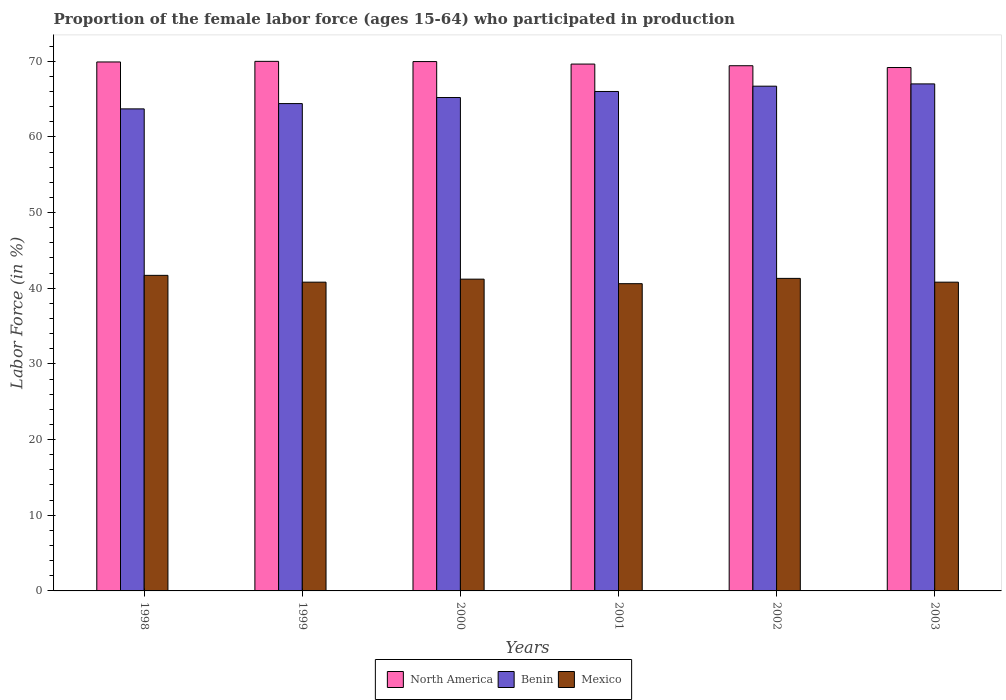How many different coloured bars are there?
Your answer should be compact. 3. How many groups of bars are there?
Provide a succinct answer. 6. Are the number of bars per tick equal to the number of legend labels?
Make the answer very short. Yes. What is the label of the 5th group of bars from the left?
Offer a terse response. 2002. In how many cases, is the number of bars for a given year not equal to the number of legend labels?
Provide a short and direct response. 0. What is the proportion of the female labor force who participated in production in North America in 2000?
Your answer should be very brief. 69.95. Across all years, what is the maximum proportion of the female labor force who participated in production in Benin?
Give a very brief answer. 67. Across all years, what is the minimum proportion of the female labor force who participated in production in Benin?
Provide a short and direct response. 63.7. What is the total proportion of the female labor force who participated in production in Benin in the graph?
Give a very brief answer. 393. What is the difference between the proportion of the female labor force who participated in production in Mexico in 2000 and that in 2002?
Your response must be concise. -0.1. What is the difference between the proportion of the female labor force who participated in production in Benin in 2000 and the proportion of the female labor force who participated in production in Mexico in 1998?
Ensure brevity in your answer.  23.5. What is the average proportion of the female labor force who participated in production in Mexico per year?
Ensure brevity in your answer.  41.07. In the year 2001, what is the difference between the proportion of the female labor force who participated in production in North America and proportion of the female labor force who participated in production in Benin?
Offer a very short reply. 3.62. What is the ratio of the proportion of the female labor force who participated in production in Benin in 1999 to that in 2002?
Keep it short and to the point. 0.97. Is the proportion of the female labor force who participated in production in Mexico in 1998 less than that in 2003?
Offer a terse response. No. What is the difference between the highest and the second highest proportion of the female labor force who participated in production in North America?
Provide a succinct answer. 0.03. What is the difference between the highest and the lowest proportion of the female labor force who participated in production in Benin?
Give a very brief answer. 3.3. In how many years, is the proportion of the female labor force who participated in production in North America greater than the average proportion of the female labor force who participated in production in North America taken over all years?
Your answer should be very brief. 3. Is the sum of the proportion of the female labor force who participated in production in Benin in 2002 and 2003 greater than the maximum proportion of the female labor force who participated in production in North America across all years?
Provide a short and direct response. Yes. What does the 1st bar from the left in 1999 represents?
Your answer should be very brief. North America. What does the 2nd bar from the right in 1998 represents?
Provide a short and direct response. Benin. Are all the bars in the graph horizontal?
Your answer should be compact. No. Are the values on the major ticks of Y-axis written in scientific E-notation?
Provide a succinct answer. No. Does the graph contain any zero values?
Keep it short and to the point. No. Does the graph contain grids?
Keep it short and to the point. No. Where does the legend appear in the graph?
Ensure brevity in your answer.  Bottom center. How many legend labels are there?
Give a very brief answer. 3. How are the legend labels stacked?
Offer a terse response. Horizontal. What is the title of the graph?
Make the answer very short. Proportion of the female labor force (ages 15-64) who participated in production. What is the label or title of the X-axis?
Your response must be concise. Years. What is the Labor Force (in %) in North America in 1998?
Give a very brief answer. 69.9. What is the Labor Force (in %) of Benin in 1998?
Provide a succinct answer. 63.7. What is the Labor Force (in %) of Mexico in 1998?
Ensure brevity in your answer.  41.7. What is the Labor Force (in %) of North America in 1999?
Provide a short and direct response. 69.98. What is the Labor Force (in %) of Benin in 1999?
Offer a very short reply. 64.4. What is the Labor Force (in %) of Mexico in 1999?
Make the answer very short. 40.8. What is the Labor Force (in %) in North America in 2000?
Offer a very short reply. 69.95. What is the Labor Force (in %) of Benin in 2000?
Provide a short and direct response. 65.2. What is the Labor Force (in %) of Mexico in 2000?
Offer a very short reply. 41.2. What is the Labor Force (in %) of North America in 2001?
Offer a terse response. 69.62. What is the Labor Force (in %) of Mexico in 2001?
Provide a succinct answer. 40.6. What is the Labor Force (in %) of North America in 2002?
Ensure brevity in your answer.  69.4. What is the Labor Force (in %) of Benin in 2002?
Provide a succinct answer. 66.7. What is the Labor Force (in %) in Mexico in 2002?
Make the answer very short. 41.3. What is the Labor Force (in %) of North America in 2003?
Make the answer very short. 69.16. What is the Labor Force (in %) in Mexico in 2003?
Make the answer very short. 40.8. Across all years, what is the maximum Labor Force (in %) of North America?
Make the answer very short. 69.98. Across all years, what is the maximum Labor Force (in %) of Benin?
Offer a terse response. 67. Across all years, what is the maximum Labor Force (in %) in Mexico?
Your response must be concise. 41.7. Across all years, what is the minimum Labor Force (in %) in North America?
Provide a succinct answer. 69.16. Across all years, what is the minimum Labor Force (in %) in Benin?
Your answer should be compact. 63.7. Across all years, what is the minimum Labor Force (in %) of Mexico?
Your answer should be compact. 40.6. What is the total Labor Force (in %) in North America in the graph?
Offer a very short reply. 418.02. What is the total Labor Force (in %) in Benin in the graph?
Your response must be concise. 393. What is the total Labor Force (in %) in Mexico in the graph?
Offer a very short reply. 246.4. What is the difference between the Labor Force (in %) of North America in 1998 and that in 1999?
Your answer should be compact. -0.08. What is the difference between the Labor Force (in %) of Benin in 1998 and that in 1999?
Your response must be concise. -0.7. What is the difference between the Labor Force (in %) of Mexico in 1998 and that in 1999?
Provide a succinct answer. 0.9. What is the difference between the Labor Force (in %) of North America in 1998 and that in 2000?
Your response must be concise. -0.05. What is the difference between the Labor Force (in %) of Benin in 1998 and that in 2000?
Provide a succinct answer. -1.5. What is the difference between the Labor Force (in %) of North America in 1998 and that in 2001?
Provide a short and direct response. 0.28. What is the difference between the Labor Force (in %) in Benin in 1998 and that in 2001?
Provide a succinct answer. -2.3. What is the difference between the Labor Force (in %) of North America in 1998 and that in 2002?
Provide a short and direct response. 0.5. What is the difference between the Labor Force (in %) of North America in 1998 and that in 2003?
Your answer should be compact. 0.74. What is the difference between the Labor Force (in %) in Benin in 1998 and that in 2003?
Your answer should be compact. -3.3. What is the difference between the Labor Force (in %) of North America in 1999 and that in 2000?
Offer a very short reply. 0.03. What is the difference between the Labor Force (in %) in Benin in 1999 and that in 2000?
Offer a terse response. -0.8. What is the difference between the Labor Force (in %) in Mexico in 1999 and that in 2000?
Keep it short and to the point. -0.4. What is the difference between the Labor Force (in %) of North America in 1999 and that in 2001?
Provide a succinct answer. 0.36. What is the difference between the Labor Force (in %) in Benin in 1999 and that in 2001?
Make the answer very short. -1.6. What is the difference between the Labor Force (in %) of North America in 1999 and that in 2002?
Make the answer very short. 0.58. What is the difference between the Labor Force (in %) of North America in 1999 and that in 2003?
Offer a terse response. 0.82. What is the difference between the Labor Force (in %) of Benin in 1999 and that in 2003?
Provide a short and direct response. -2.6. What is the difference between the Labor Force (in %) in Mexico in 1999 and that in 2003?
Keep it short and to the point. 0. What is the difference between the Labor Force (in %) of North America in 2000 and that in 2001?
Give a very brief answer. 0.33. What is the difference between the Labor Force (in %) in Benin in 2000 and that in 2001?
Keep it short and to the point. -0.8. What is the difference between the Labor Force (in %) of Mexico in 2000 and that in 2001?
Keep it short and to the point. 0.6. What is the difference between the Labor Force (in %) of North America in 2000 and that in 2002?
Give a very brief answer. 0.55. What is the difference between the Labor Force (in %) of North America in 2000 and that in 2003?
Provide a short and direct response. 0.79. What is the difference between the Labor Force (in %) in Mexico in 2000 and that in 2003?
Your response must be concise. 0.4. What is the difference between the Labor Force (in %) of North America in 2001 and that in 2002?
Provide a short and direct response. 0.22. What is the difference between the Labor Force (in %) in North America in 2001 and that in 2003?
Your answer should be very brief. 0.46. What is the difference between the Labor Force (in %) in Benin in 2001 and that in 2003?
Your answer should be compact. -1. What is the difference between the Labor Force (in %) of Mexico in 2001 and that in 2003?
Provide a succinct answer. -0.2. What is the difference between the Labor Force (in %) in North America in 2002 and that in 2003?
Offer a very short reply. 0.24. What is the difference between the Labor Force (in %) in Mexico in 2002 and that in 2003?
Give a very brief answer. 0.5. What is the difference between the Labor Force (in %) of North America in 1998 and the Labor Force (in %) of Benin in 1999?
Ensure brevity in your answer.  5.5. What is the difference between the Labor Force (in %) in North America in 1998 and the Labor Force (in %) in Mexico in 1999?
Keep it short and to the point. 29.1. What is the difference between the Labor Force (in %) of Benin in 1998 and the Labor Force (in %) of Mexico in 1999?
Your answer should be compact. 22.9. What is the difference between the Labor Force (in %) in North America in 1998 and the Labor Force (in %) in Benin in 2000?
Give a very brief answer. 4.7. What is the difference between the Labor Force (in %) in North America in 1998 and the Labor Force (in %) in Mexico in 2000?
Offer a very short reply. 28.7. What is the difference between the Labor Force (in %) of North America in 1998 and the Labor Force (in %) of Benin in 2001?
Your answer should be very brief. 3.9. What is the difference between the Labor Force (in %) in North America in 1998 and the Labor Force (in %) in Mexico in 2001?
Offer a terse response. 29.3. What is the difference between the Labor Force (in %) in Benin in 1998 and the Labor Force (in %) in Mexico in 2001?
Give a very brief answer. 23.1. What is the difference between the Labor Force (in %) of North America in 1998 and the Labor Force (in %) of Benin in 2002?
Your answer should be compact. 3.2. What is the difference between the Labor Force (in %) of North America in 1998 and the Labor Force (in %) of Mexico in 2002?
Provide a short and direct response. 28.6. What is the difference between the Labor Force (in %) in Benin in 1998 and the Labor Force (in %) in Mexico in 2002?
Provide a short and direct response. 22.4. What is the difference between the Labor Force (in %) of North America in 1998 and the Labor Force (in %) of Benin in 2003?
Your answer should be very brief. 2.9. What is the difference between the Labor Force (in %) of North America in 1998 and the Labor Force (in %) of Mexico in 2003?
Ensure brevity in your answer.  29.1. What is the difference between the Labor Force (in %) in Benin in 1998 and the Labor Force (in %) in Mexico in 2003?
Your answer should be compact. 22.9. What is the difference between the Labor Force (in %) of North America in 1999 and the Labor Force (in %) of Benin in 2000?
Give a very brief answer. 4.78. What is the difference between the Labor Force (in %) of North America in 1999 and the Labor Force (in %) of Mexico in 2000?
Your answer should be very brief. 28.78. What is the difference between the Labor Force (in %) in Benin in 1999 and the Labor Force (in %) in Mexico in 2000?
Your answer should be compact. 23.2. What is the difference between the Labor Force (in %) of North America in 1999 and the Labor Force (in %) of Benin in 2001?
Your answer should be very brief. 3.98. What is the difference between the Labor Force (in %) in North America in 1999 and the Labor Force (in %) in Mexico in 2001?
Give a very brief answer. 29.38. What is the difference between the Labor Force (in %) of Benin in 1999 and the Labor Force (in %) of Mexico in 2001?
Make the answer very short. 23.8. What is the difference between the Labor Force (in %) in North America in 1999 and the Labor Force (in %) in Benin in 2002?
Offer a terse response. 3.28. What is the difference between the Labor Force (in %) of North America in 1999 and the Labor Force (in %) of Mexico in 2002?
Provide a short and direct response. 28.68. What is the difference between the Labor Force (in %) of Benin in 1999 and the Labor Force (in %) of Mexico in 2002?
Keep it short and to the point. 23.1. What is the difference between the Labor Force (in %) of North America in 1999 and the Labor Force (in %) of Benin in 2003?
Your answer should be very brief. 2.98. What is the difference between the Labor Force (in %) in North America in 1999 and the Labor Force (in %) in Mexico in 2003?
Your answer should be very brief. 29.18. What is the difference between the Labor Force (in %) in Benin in 1999 and the Labor Force (in %) in Mexico in 2003?
Your answer should be compact. 23.6. What is the difference between the Labor Force (in %) of North America in 2000 and the Labor Force (in %) of Benin in 2001?
Ensure brevity in your answer.  3.95. What is the difference between the Labor Force (in %) in North America in 2000 and the Labor Force (in %) in Mexico in 2001?
Your answer should be compact. 29.35. What is the difference between the Labor Force (in %) of Benin in 2000 and the Labor Force (in %) of Mexico in 2001?
Give a very brief answer. 24.6. What is the difference between the Labor Force (in %) of North America in 2000 and the Labor Force (in %) of Benin in 2002?
Make the answer very short. 3.25. What is the difference between the Labor Force (in %) in North America in 2000 and the Labor Force (in %) in Mexico in 2002?
Provide a succinct answer. 28.65. What is the difference between the Labor Force (in %) in Benin in 2000 and the Labor Force (in %) in Mexico in 2002?
Your response must be concise. 23.9. What is the difference between the Labor Force (in %) of North America in 2000 and the Labor Force (in %) of Benin in 2003?
Give a very brief answer. 2.95. What is the difference between the Labor Force (in %) in North America in 2000 and the Labor Force (in %) in Mexico in 2003?
Your answer should be compact. 29.15. What is the difference between the Labor Force (in %) of Benin in 2000 and the Labor Force (in %) of Mexico in 2003?
Your answer should be compact. 24.4. What is the difference between the Labor Force (in %) in North America in 2001 and the Labor Force (in %) in Benin in 2002?
Offer a very short reply. 2.92. What is the difference between the Labor Force (in %) in North America in 2001 and the Labor Force (in %) in Mexico in 2002?
Offer a very short reply. 28.32. What is the difference between the Labor Force (in %) of Benin in 2001 and the Labor Force (in %) of Mexico in 2002?
Give a very brief answer. 24.7. What is the difference between the Labor Force (in %) of North America in 2001 and the Labor Force (in %) of Benin in 2003?
Provide a short and direct response. 2.62. What is the difference between the Labor Force (in %) in North America in 2001 and the Labor Force (in %) in Mexico in 2003?
Provide a succinct answer. 28.82. What is the difference between the Labor Force (in %) in Benin in 2001 and the Labor Force (in %) in Mexico in 2003?
Give a very brief answer. 25.2. What is the difference between the Labor Force (in %) in North America in 2002 and the Labor Force (in %) in Benin in 2003?
Your answer should be compact. 2.4. What is the difference between the Labor Force (in %) of North America in 2002 and the Labor Force (in %) of Mexico in 2003?
Ensure brevity in your answer.  28.6. What is the difference between the Labor Force (in %) of Benin in 2002 and the Labor Force (in %) of Mexico in 2003?
Your answer should be very brief. 25.9. What is the average Labor Force (in %) of North America per year?
Provide a short and direct response. 69.67. What is the average Labor Force (in %) in Benin per year?
Your response must be concise. 65.5. What is the average Labor Force (in %) in Mexico per year?
Ensure brevity in your answer.  41.07. In the year 1998, what is the difference between the Labor Force (in %) in North America and Labor Force (in %) in Benin?
Provide a short and direct response. 6.2. In the year 1998, what is the difference between the Labor Force (in %) of North America and Labor Force (in %) of Mexico?
Provide a short and direct response. 28.2. In the year 1998, what is the difference between the Labor Force (in %) in Benin and Labor Force (in %) in Mexico?
Your answer should be very brief. 22. In the year 1999, what is the difference between the Labor Force (in %) in North America and Labor Force (in %) in Benin?
Offer a terse response. 5.58. In the year 1999, what is the difference between the Labor Force (in %) in North America and Labor Force (in %) in Mexico?
Your answer should be compact. 29.18. In the year 1999, what is the difference between the Labor Force (in %) in Benin and Labor Force (in %) in Mexico?
Make the answer very short. 23.6. In the year 2000, what is the difference between the Labor Force (in %) of North America and Labor Force (in %) of Benin?
Your answer should be very brief. 4.75. In the year 2000, what is the difference between the Labor Force (in %) in North America and Labor Force (in %) in Mexico?
Your response must be concise. 28.75. In the year 2001, what is the difference between the Labor Force (in %) in North America and Labor Force (in %) in Benin?
Provide a succinct answer. 3.62. In the year 2001, what is the difference between the Labor Force (in %) of North America and Labor Force (in %) of Mexico?
Keep it short and to the point. 29.02. In the year 2001, what is the difference between the Labor Force (in %) in Benin and Labor Force (in %) in Mexico?
Keep it short and to the point. 25.4. In the year 2002, what is the difference between the Labor Force (in %) of North America and Labor Force (in %) of Benin?
Keep it short and to the point. 2.7. In the year 2002, what is the difference between the Labor Force (in %) in North America and Labor Force (in %) in Mexico?
Your answer should be very brief. 28.1. In the year 2002, what is the difference between the Labor Force (in %) in Benin and Labor Force (in %) in Mexico?
Offer a very short reply. 25.4. In the year 2003, what is the difference between the Labor Force (in %) in North America and Labor Force (in %) in Benin?
Your answer should be very brief. 2.16. In the year 2003, what is the difference between the Labor Force (in %) in North America and Labor Force (in %) in Mexico?
Make the answer very short. 28.36. In the year 2003, what is the difference between the Labor Force (in %) of Benin and Labor Force (in %) of Mexico?
Give a very brief answer. 26.2. What is the ratio of the Labor Force (in %) of Mexico in 1998 to that in 1999?
Offer a terse response. 1.02. What is the ratio of the Labor Force (in %) of Benin in 1998 to that in 2000?
Offer a very short reply. 0.98. What is the ratio of the Labor Force (in %) of Mexico in 1998 to that in 2000?
Ensure brevity in your answer.  1.01. What is the ratio of the Labor Force (in %) in Benin in 1998 to that in 2001?
Ensure brevity in your answer.  0.97. What is the ratio of the Labor Force (in %) of Mexico in 1998 to that in 2001?
Offer a terse response. 1.03. What is the ratio of the Labor Force (in %) in Benin in 1998 to that in 2002?
Keep it short and to the point. 0.95. What is the ratio of the Labor Force (in %) of Mexico in 1998 to that in 2002?
Your answer should be very brief. 1.01. What is the ratio of the Labor Force (in %) in North America in 1998 to that in 2003?
Your response must be concise. 1.01. What is the ratio of the Labor Force (in %) in Benin in 1998 to that in 2003?
Give a very brief answer. 0.95. What is the ratio of the Labor Force (in %) in Mexico in 1998 to that in 2003?
Give a very brief answer. 1.02. What is the ratio of the Labor Force (in %) in North America in 1999 to that in 2000?
Your answer should be compact. 1. What is the ratio of the Labor Force (in %) in Mexico in 1999 to that in 2000?
Provide a succinct answer. 0.99. What is the ratio of the Labor Force (in %) in North America in 1999 to that in 2001?
Offer a terse response. 1.01. What is the ratio of the Labor Force (in %) in Benin in 1999 to that in 2001?
Offer a very short reply. 0.98. What is the ratio of the Labor Force (in %) in Mexico in 1999 to that in 2001?
Your response must be concise. 1. What is the ratio of the Labor Force (in %) of North America in 1999 to that in 2002?
Provide a short and direct response. 1.01. What is the ratio of the Labor Force (in %) in Benin in 1999 to that in 2002?
Your answer should be compact. 0.97. What is the ratio of the Labor Force (in %) of Mexico in 1999 to that in 2002?
Give a very brief answer. 0.99. What is the ratio of the Labor Force (in %) of North America in 1999 to that in 2003?
Make the answer very short. 1.01. What is the ratio of the Labor Force (in %) of Benin in 1999 to that in 2003?
Offer a very short reply. 0.96. What is the ratio of the Labor Force (in %) of North America in 2000 to that in 2001?
Give a very brief answer. 1. What is the ratio of the Labor Force (in %) in Benin in 2000 to that in 2001?
Give a very brief answer. 0.99. What is the ratio of the Labor Force (in %) of Mexico in 2000 to that in 2001?
Make the answer very short. 1.01. What is the ratio of the Labor Force (in %) of North America in 2000 to that in 2002?
Offer a terse response. 1.01. What is the ratio of the Labor Force (in %) of Benin in 2000 to that in 2002?
Keep it short and to the point. 0.98. What is the ratio of the Labor Force (in %) of North America in 2000 to that in 2003?
Keep it short and to the point. 1.01. What is the ratio of the Labor Force (in %) of Benin in 2000 to that in 2003?
Offer a very short reply. 0.97. What is the ratio of the Labor Force (in %) in Mexico in 2000 to that in 2003?
Keep it short and to the point. 1.01. What is the ratio of the Labor Force (in %) of North America in 2001 to that in 2002?
Make the answer very short. 1. What is the ratio of the Labor Force (in %) of Benin in 2001 to that in 2002?
Your response must be concise. 0.99. What is the ratio of the Labor Force (in %) of Mexico in 2001 to that in 2002?
Give a very brief answer. 0.98. What is the ratio of the Labor Force (in %) in North America in 2001 to that in 2003?
Keep it short and to the point. 1.01. What is the ratio of the Labor Force (in %) in Benin in 2001 to that in 2003?
Ensure brevity in your answer.  0.99. What is the ratio of the Labor Force (in %) of Mexico in 2001 to that in 2003?
Provide a short and direct response. 1. What is the ratio of the Labor Force (in %) of North America in 2002 to that in 2003?
Offer a very short reply. 1. What is the ratio of the Labor Force (in %) in Benin in 2002 to that in 2003?
Keep it short and to the point. 1. What is the ratio of the Labor Force (in %) of Mexico in 2002 to that in 2003?
Make the answer very short. 1.01. What is the difference between the highest and the second highest Labor Force (in %) of North America?
Keep it short and to the point. 0.03. What is the difference between the highest and the second highest Labor Force (in %) of Benin?
Offer a very short reply. 0.3. What is the difference between the highest and the second highest Labor Force (in %) of Mexico?
Provide a succinct answer. 0.4. What is the difference between the highest and the lowest Labor Force (in %) in North America?
Give a very brief answer. 0.82. What is the difference between the highest and the lowest Labor Force (in %) of Benin?
Give a very brief answer. 3.3. What is the difference between the highest and the lowest Labor Force (in %) of Mexico?
Provide a succinct answer. 1.1. 